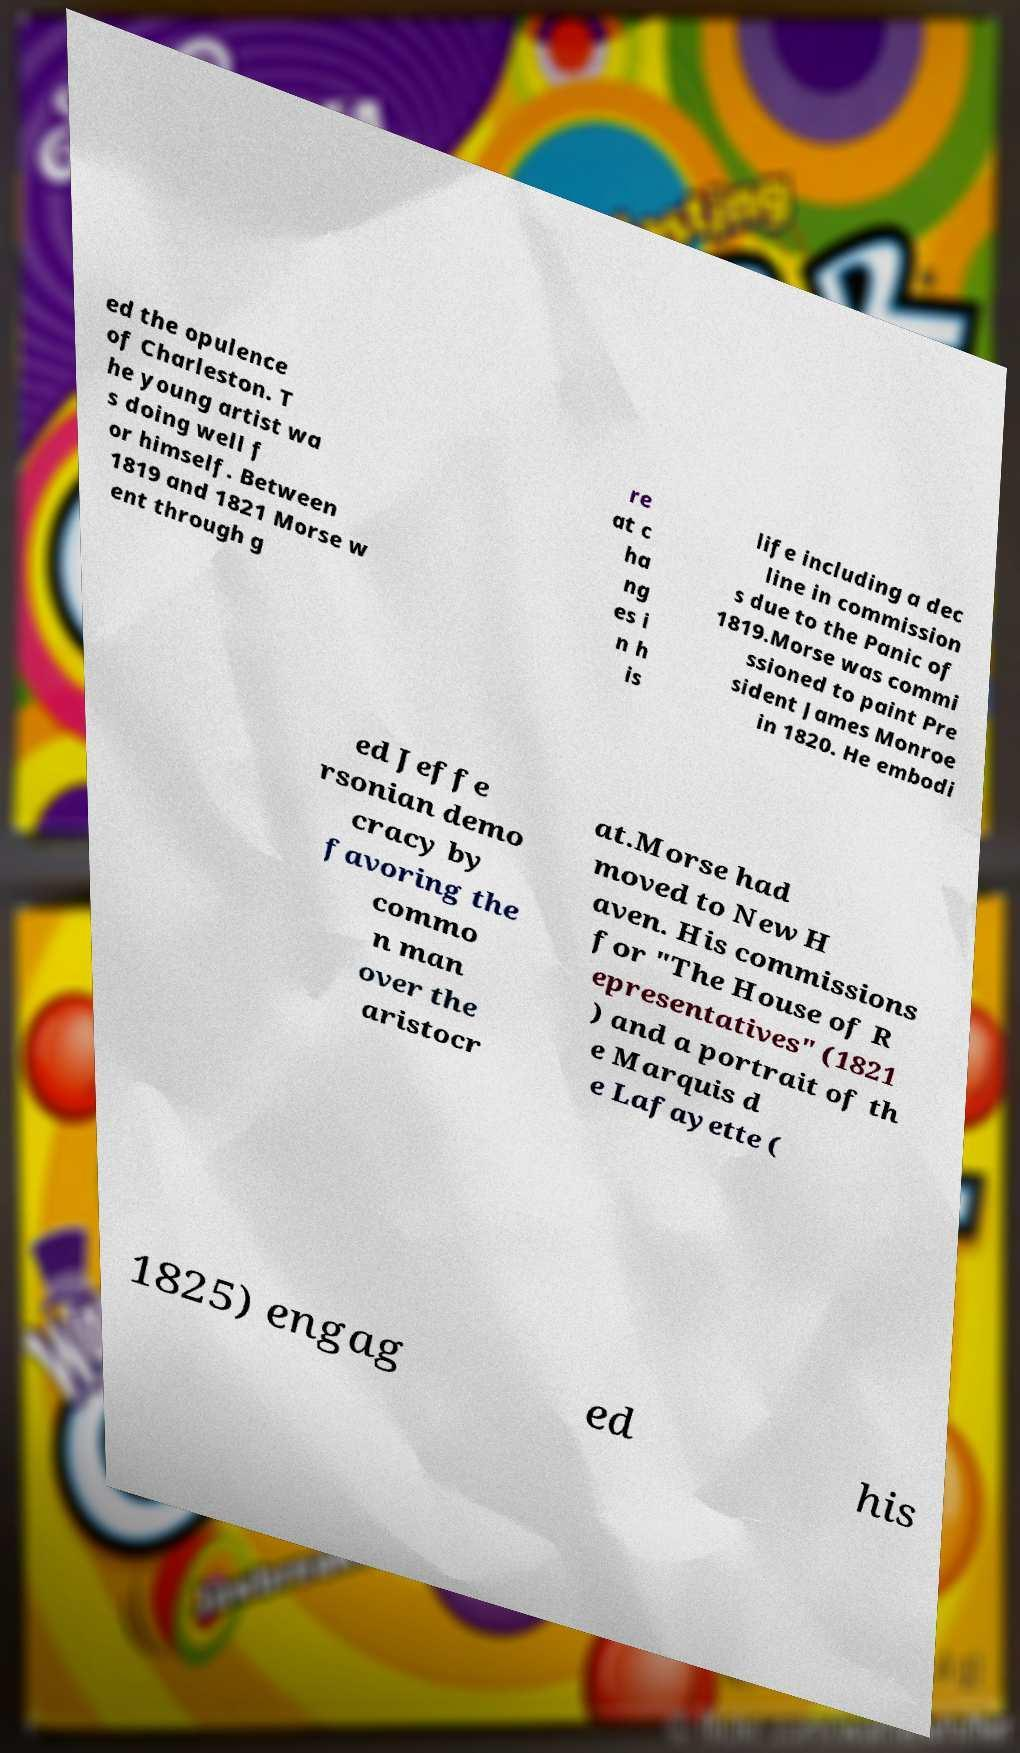Could you assist in decoding the text presented in this image and type it out clearly? ed the opulence of Charleston. T he young artist wa s doing well f or himself. Between 1819 and 1821 Morse w ent through g re at c ha ng es i n h is life including a dec line in commission s due to the Panic of 1819.Morse was commi ssioned to paint Pre sident James Monroe in 1820. He embodi ed Jeffe rsonian demo cracy by favoring the commo n man over the aristocr at.Morse had moved to New H aven. His commissions for "The House of R epresentatives" (1821 ) and a portrait of th e Marquis d e Lafayette ( 1825) engag ed his 